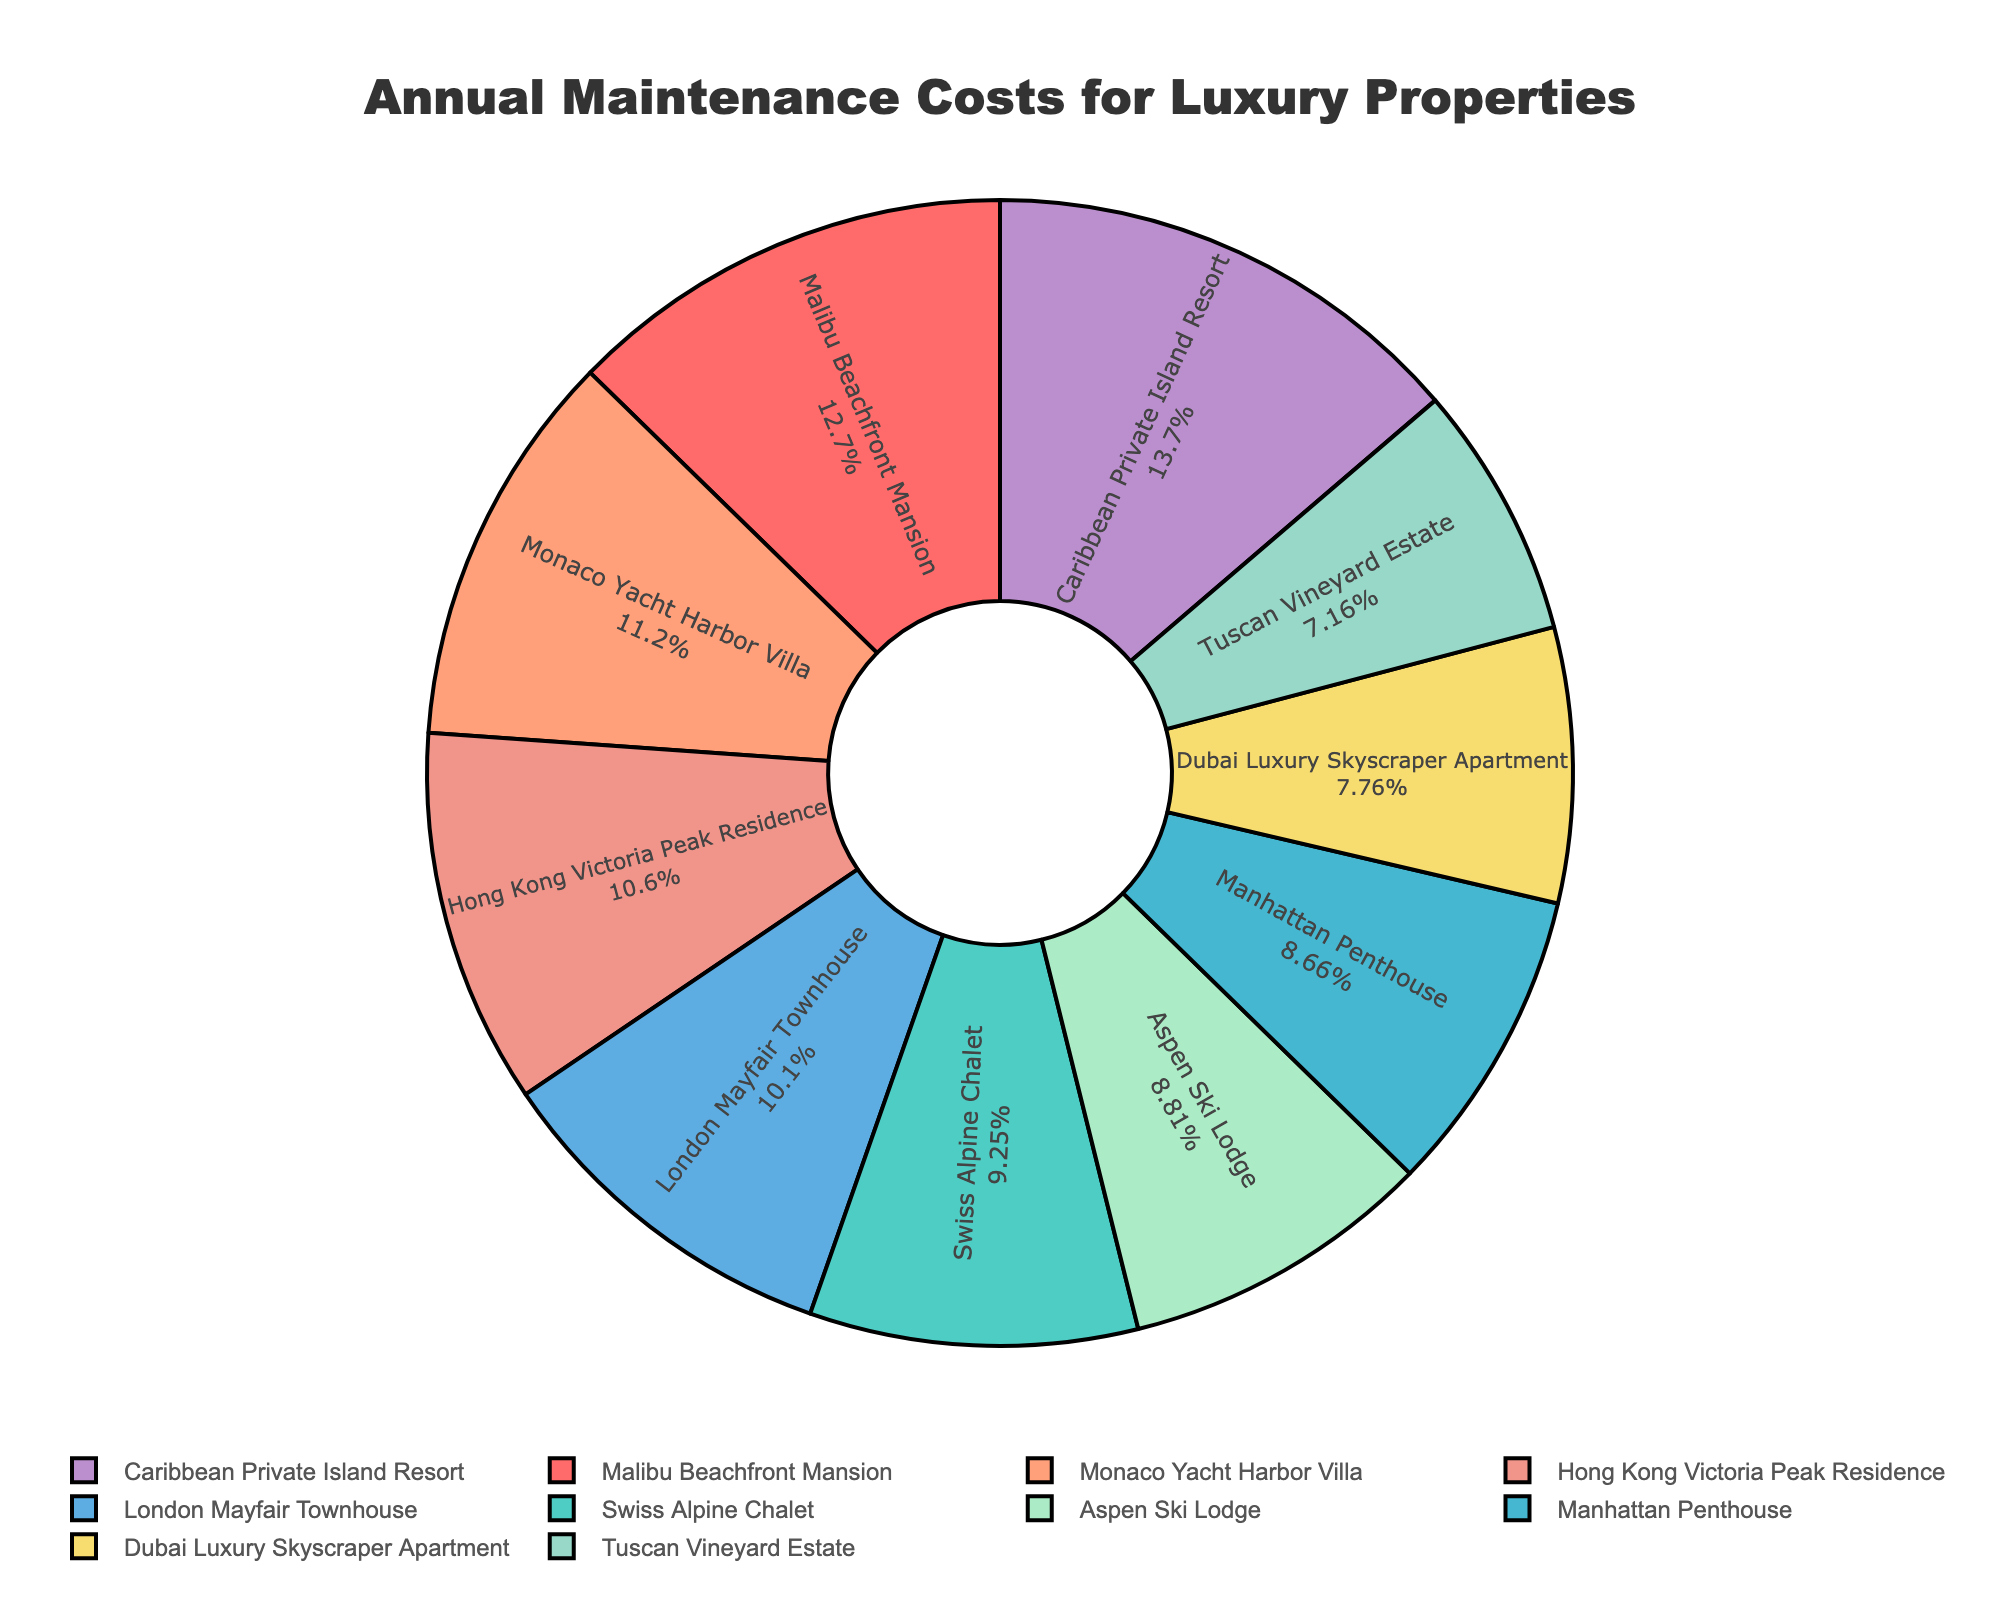Which property has the highest annual maintenance cost? To identify the property with the highest annual maintenance cost, look for the largest section of the pie chart. The Caribbean Private Island Resort has the largest section, indicating the highest cost of $920,000.
Answer: Caribbean Private Island Resort Which property has the lowest annual maintenance cost? To find the property with the lowest annual maintenance cost, look for the smallest section of the pie chart. The Tuscan Vineyard Estate has the smallest section, indicating the lowest cost of $480,000.
Answer: Tuscan Vineyard Estate What percentage of the total annual maintenance costs is spent on the Malibu Beachfront Mansion? Look at the section of the pie chart labeled Malibu Beachfront Mansion and note its percentage. The Malibu Beachfront Mansion's section is labeled with its percentage of the total costs.
Answer: 14.7% How do the maintenance costs of the Swiss Alpine Chalet and the Aspen Ski Lodge compare? Find the sections for the Swiss Alpine Chalet and the Aspen Ski Lodge. Note their values. The Swiss Alpine Chalet has a maintenance cost of $620,000, and the Aspen Ski Lodge has a cost of $590,000. The Swiss Alpine Chalet has a higher cost.
Answer: Swiss Alpine Chalet has higher cost What is the combined annual maintenance cost of the Malibu Beachfront Mansion and the Monaco Yacht Harbor Villa? Locate the values of the Malibu Beachfront Mansion and Monaco Yacht Harbor Villa on the pie chart. Their costs are $850,000 and $750,000, respectively. Add these values to find the combined cost: $850,000 + $750,000 = $1,600,000.
Answer: $1,600,000 Which property is represented by the blue color on the pie chart? Identify the section of the pie chart colored blue. The Manhattan Penthouse is represented by blue color.
Answer: Manhattan Penthouse What is the ratio of the annual maintenance cost of the Caribbean Private Island Resort to the Tuscan Vineyard Estate? Note the annual maintenance costs of both properties from the pie chart. The Caribbean Private Island Resort has a cost of $920,000, and the Tuscan Vineyard Estate has a cost of $480,000. The ratio is $920,000 : $480,000, simplifying to 23:12.
Answer: 23:12 What is the average annual maintenance cost of the properties listed? Add all the maintenance costs together and divide by the number of properties. Sum: $850,000 + $620,000 + $580,000 + $750,000 + $480,000 + $520,000 + $920,000 + $680,000 + $710,000 + $590,000 = $6,700,000. Divide by 10 properties: $6,700,000 ÷ 10 = $670,000.
Answer: $670,000 Which property types have maintenance costs above the average annual maintenance cost? First, find the average maintenance cost which is $670,000. Then compare each property's cost against this average. The Malibu Beachfront Mansion ($850,000), Monaco Yacht Harbor Villa ($750,000), Caribbean Private Island Resort ($920,000), London Mayfair Townhouse ($680,000), and Hong Kong Victoria Peak Residence ($710,000) have costs above the average.
Answer: Malibu Beachfront Mansion, Monaco Yacht Harbor Villa, Caribbean Private Island Resort, London Mayfair Townhouse, Hong Kong Victoria Peak Residence 